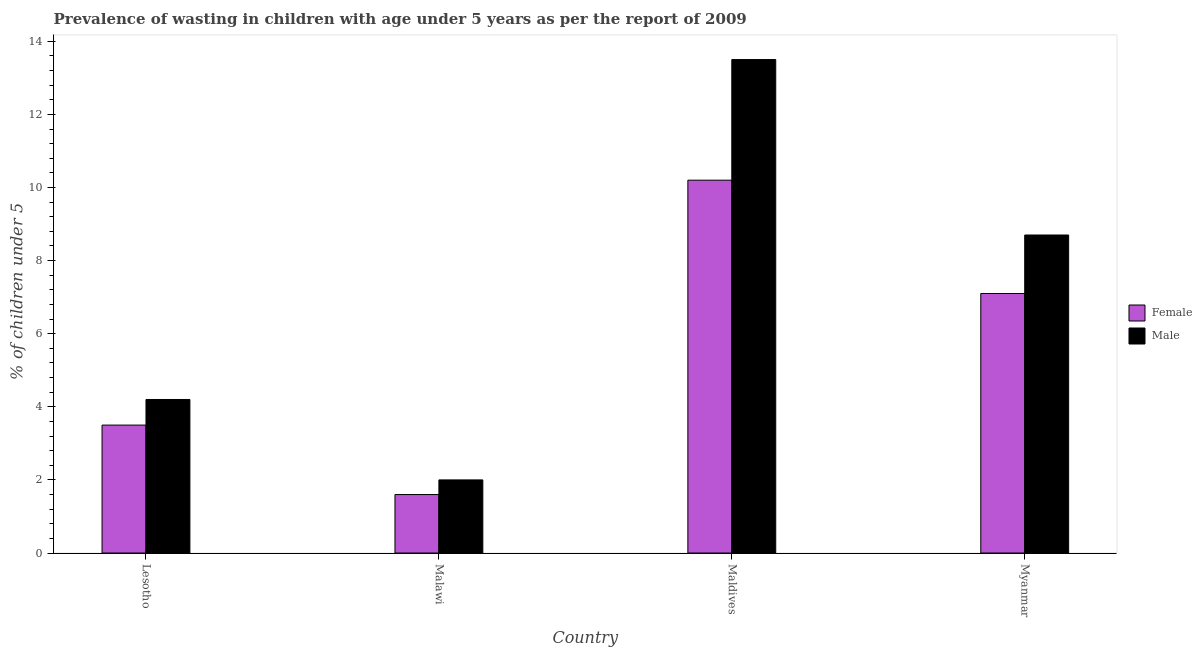How many different coloured bars are there?
Make the answer very short. 2. How many bars are there on the 2nd tick from the right?
Your response must be concise. 2. What is the label of the 3rd group of bars from the left?
Provide a succinct answer. Maldives. What is the percentage of undernourished female children in Myanmar?
Offer a terse response. 7.1. Across all countries, what is the maximum percentage of undernourished male children?
Offer a very short reply. 13.5. In which country was the percentage of undernourished female children maximum?
Make the answer very short. Maldives. In which country was the percentage of undernourished male children minimum?
Keep it short and to the point. Malawi. What is the total percentage of undernourished female children in the graph?
Your response must be concise. 22.4. What is the difference between the percentage of undernourished male children in Maldives and that in Myanmar?
Provide a short and direct response. 4.8. What is the difference between the percentage of undernourished male children in Maldives and the percentage of undernourished female children in Malawi?
Your answer should be compact. 11.9. What is the average percentage of undernourished female children per country?
Your response must be concise. 5.6. What is the difference between the percentage of undernourished male children and percentage of undernourished female children in Maldives?
Provide a short and direct response. 3.3. In how many countries, is the percentage of undernourished male children greater than 8 %?
Your response must be concise. 2. What is the ratio of the percentage of undernourished female children in Malawi to that in Myanmar?
Offer a terse response. 0.23. Is the percentage of undernourished female children in Malawi less than that in Myanmar?
Make the answer very short. Yes. Is the difference between the percentage of undernourished male children in Lesotho and Malawi greater than the difference between the percentage of undernourished female children in Lesotho and Malawi?
Make the answer very short. Yes. What is the difference between the highest and the second highest percentage of undernourished male children?
Offer a very short reply. 4.8. What is the difference between the highest and the lowest percentage of undernourished female children?
Offer a very short reply. 8.6. Is the sum of the percentage of undernourished female children in Malawi and Maldives greater than the maximum percentage of undernourished male children across all countries?
Offer a very short reply. No. Are all the bars in the graph horizontal?
Your answer should be compact. No. How many countries are there in the graph?
Your answer should be very brief. 4. Are the values on the major ticks of Y-axis written in scientific E-notation?
Ensure brevity in your answer.  No. Where does the legend appear in the graph?
Make the answer very short. Center right. How are the legend labels stacked?
Make the answer very short. Vertical. What is the title of the graph?
Provide a succinct answer. Prevalence of wasting in children with age under 5 years as per the report of 2009. What is the label or title of the Y-axis?
Give a very brief answer.  % of children under 5. What is the  % of children under 5 of Female in Lesotho?
Your answer should be very brief. 3.5. What is the  % of children under 5 in Male in Lesotho?
Offer a very short reply. 4.2. What is the  % of children under 5 in Female in Malawi?
Offer a very short reply. 1.6. What is the  % of children under 5 of Male in Malawi?
Provide a succinct answer. 2. What is the  % of children under 5 of Female in Maldives?
Provide a succinct answer. 10.2. What is the  % of children under 5 of Male in Maldives?
Give a very brief answer. 13.5. What is the  % of children under 5 of Female in Myanmar?
Your response must be concise. 7.1. What is the  % of children under 5 of Male in Myanmar?
Give a very brief answer. 8.7. Across all countries, what is the maximum  % of children under 5 in Female?
Your answer should be compact. 10.2. Across all countries, what is the minimum  % of children under 5 of Female?
Your answer should be very brief. 1.6. Across all countries, what is the minimum  % of children under 5 of Male?
Give a very brief answer. 2. What is the total  % of children under 5 in Female in the graph?
Your answer should be compact. 22.4. What is the total  % of children under 5 in Male in the graph?
Keep it short and to the point. 28.4. What is the difference between the  % of children under 5 in Female in Lesotho and that in Malawi?
Your response must be concise. 1.9. What is the difference between the  % of children under 5 in Female in Lesotho and that in Maldives?
Keep it short and to the point. -6.7. What is the difference between the  % of children under 5 of Female in Lesotho and that in Myanmar?
Your answer should be very brief. -3.6. What is the difference between the  % of children under 5 in Male in Lesotho and that in Myanmar?
Your response must be concise. -4.5. What is the difference between the  % of children under 5 in Male in Malawi and that in Myanmar?
Give a very brief answer. -6.7. What is the difference between the  % of children under 5 in Male in Maldives and that in Myanmar?
Provide a short and direct response. 4.8. What is the difference between the  % of children under 5 of Female in Lesotho and the  % of children under 5 of Male in Malawi?
Your answer should be very brief. 1.5. What is the difference between the  % of children under 5 in Female in Lesotho and the  % of children under 5 in Male in Maldives?
Make the answer very short. -10. What is the difference between the  % of children under 5 of Female in Malawi and the  % of children under 5 of Male in Maldives?
Provide a succinct answer. -11.9. What is the difference between the  % of children under 5 of Female and  % of children under 5 of Male in Lesotho?
Provide a succinct answer. -0.7. What is the difference between the  % of children under 5 of Female and  % of children under 5 of Male in Malawi?
Provide a succinct answer. -0.4. What is the difference between the  % of children under 5 of Female and  % of children under 5 of Male in Maldives?
Offer a terse response. -3.3. What is the ratio of the  % of children under 5 of Female in Lesotho to that in Malawi?
Your response must be concise. 2.19. What is the ratio of the  % of children under 5 of Male in Lesotho to that in Malawi?
Give a very brief answer. 2.1. What is the ratio of the  % of children under 5 of Female in Lesotho to that in Maldives?
Keep it short and to the point. 0.34. What is the ratio of the  % of children under 5 of Male in Lesotho to that in Maldives?
Your response must be concise. 0.31. What is the ratio of the  % of children under 5 in Female in Lesotho to that in Myanmar?
Your answer should be compact. 0.49. What is the ratio of the  % of children under 5 in Male in Lesotho to that in Myanmar?
Offer a very short reply. 0.48. What is the ratio of the  % of children under 5 of Female in Malawi to that in Maldives?
Your answer should be compact. 0.16. What is the ratio of the  % of children under 5 of Male in Malawi to that in Maldives?
Ensure brevity in your answer.  0.15. What is the ratio of the  % of children under 5 of Female in Malawi to that in Myanmar?
Keep it short and to the point. 0.23. What is the ratio of the  % of children under 5 in Male in Malawi to that in Myanmar?
Your answer should be compact. 0.23. What is the ratio of the  % of children under 5 of Female in Maldives to that in Myanmar?
Offer a terse response. 1.44. What is the ratio of the  % of children under 5 of Male in Maldives to that in Myanmar?
Your response must be concise. 1.55. What is the difference between the highest and the second highest  % of children under 5 in Female?
Ensure brevity in your answer.  3.1. What is the difference between the highest and the second highest  % of children under 5 of Male?
Your answer should be compact. 4.8. What is the difference between the highest and the lowest  % of children under 5 of Female?
Make the answer very short. 8.6. 